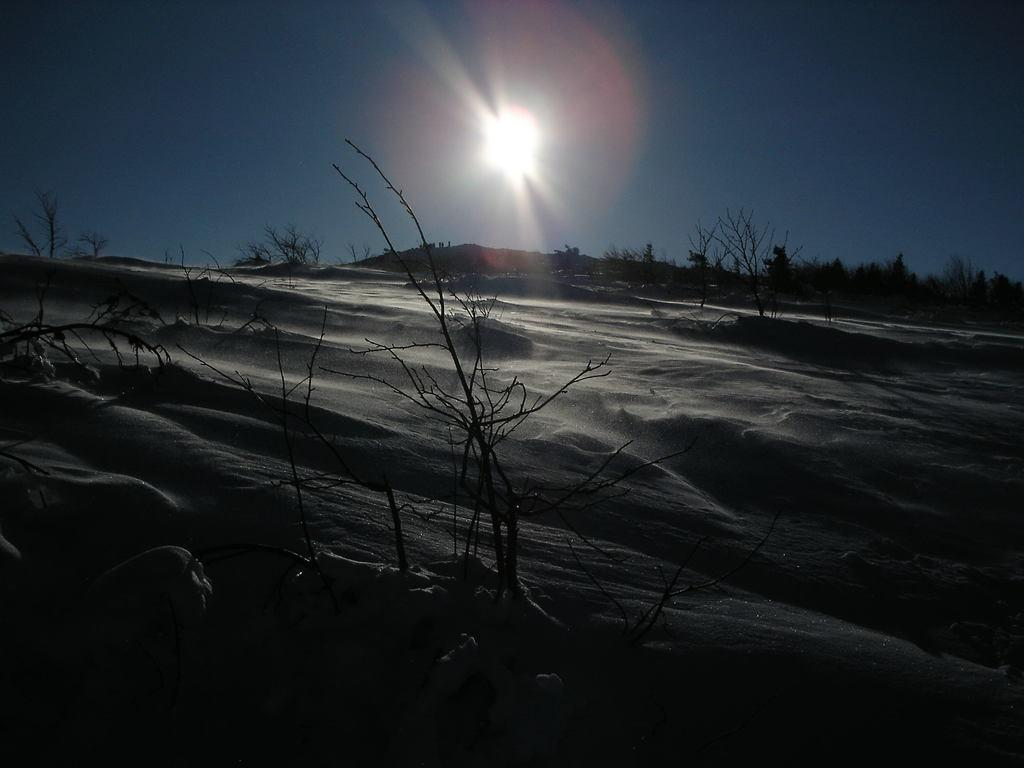What is at the top of the image? There is a sun at the top of the image. What type of living organisms can be seen in the image? Plants are visible in the image. What is covering the ground in the image? The ground appears to be covered in snow. How many servants are visible in the image? There are no servants present in the image. What is the relationship between the plants and the sun in the image? The plants and the sun are not depicted as having a relationship in the image. 